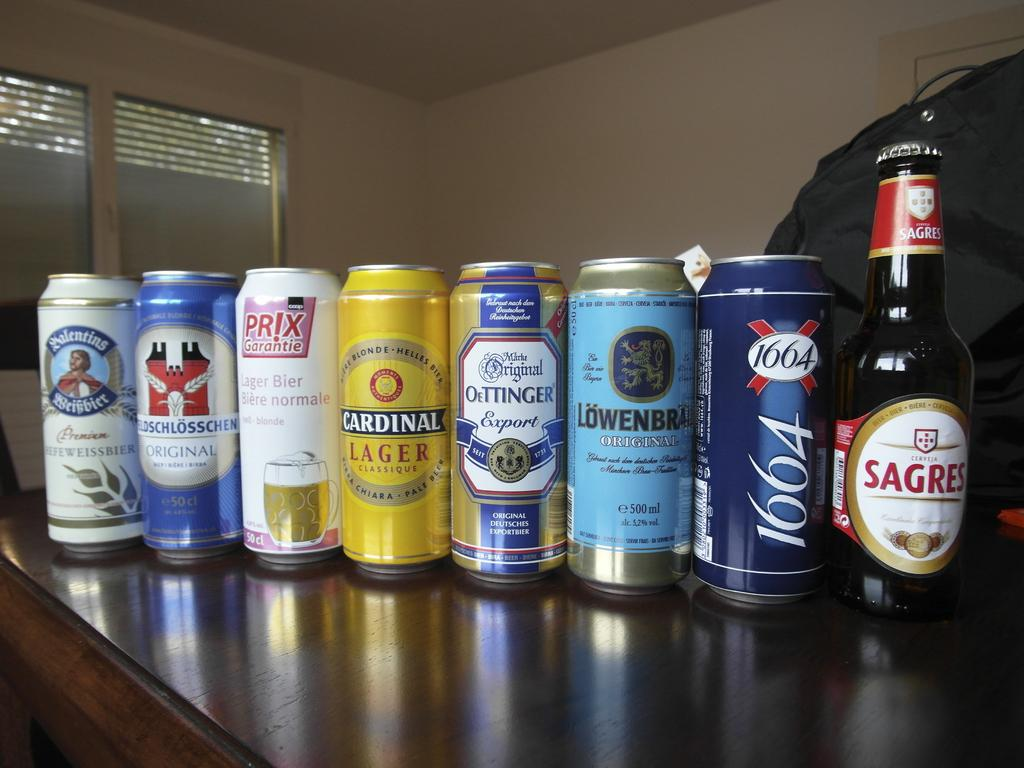<image>
Render a clear and concise summary of the photo. a row of beer cans next to a bottle of sagres 